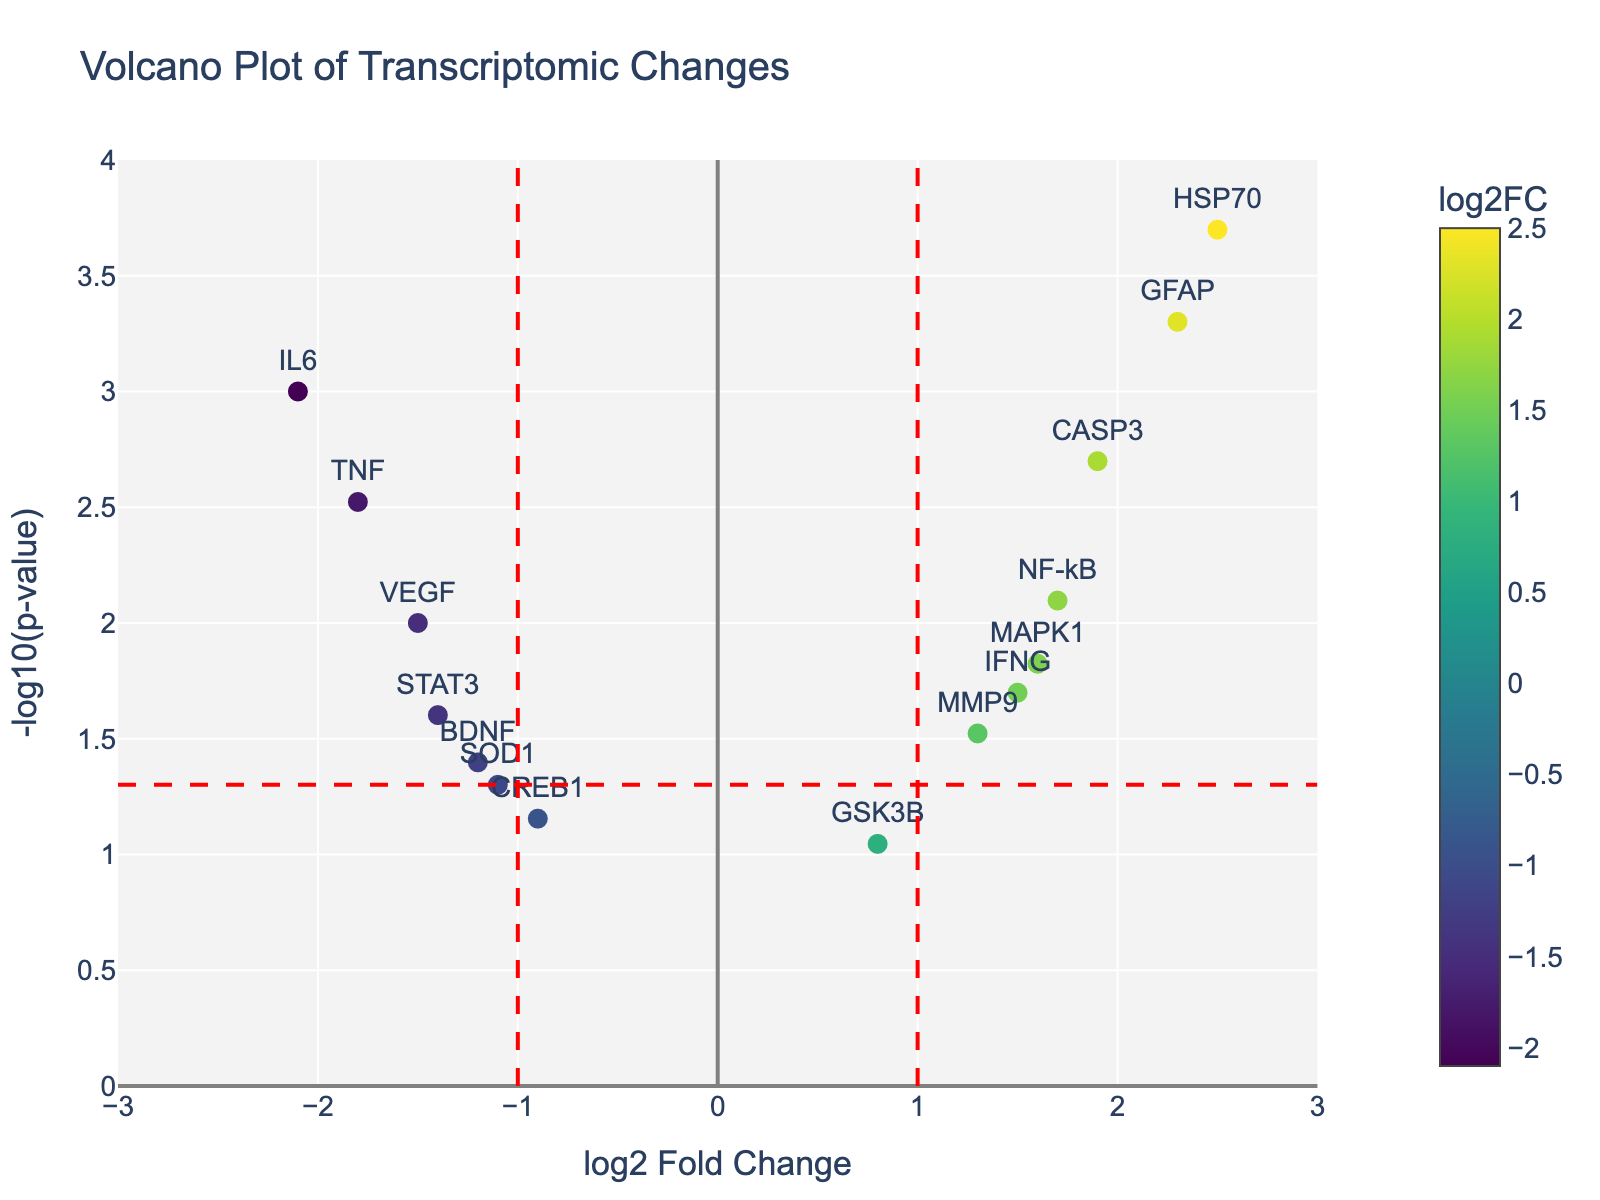How many genes have a log2 fold change greater than 1? Count the number of genes that have a log2 fold change greater than 1 on the x-axis.
Answer: 5 Which gene has the lowest p-value? Identify the data point with the highest -log10(p-value) on the y-axis, which corresponds to the lowest p-value. This gene is HSP70, standing highest on the plot.
Answer: HSP70 What is the range of log2 fold change values displayed on the x-axis? The x-axis shows values from -3 to 3 as indicated by the axis range provided in the plot settings.
Answer: -3 to 3 Are there any genes with a log2 fold change of 0? Visually scan the x-axis for any data points located at 0; none of the points are at this position.
Answer: No How many genes have significant changes (p < 0.05)? Count the number of data points above the horizontal threshold line representing p = 0.05 (-log10(0.05) on the y-axis). In this case, there are 10 points above the threshold.
Answer: 10 Which gene has the highest absolute log2 fold change? Check both ends of the x-axis; GFAP and HSP70 both have high values. The highest absolute log2 fold change is for HSP70 (2.5).
Answer: HSP70 What is the log2 fold change of the gene TNF? Locate the gene TNF on the plot by its label and read its x-axis value, which is -1.8.
Answer: -1.8 Is IL6 upregulated or downregulated? Check the position of IL6 along the x-axis; it is to the left of 0, indicating downregulation.
Answer: Downregulated Which gene lies closest to the p-value threshold of 0.05? Compare the data points near the horizontal threshold line at -log10(p-value) of 0.05; BDNF is slightly above while SOD1 is slightly below, making BDNF the correct answer as it crosses the threshold.
Answer: BDNF What is the color scheme used for the marker sizes in the plot? The question addresses the general style used for the markers, which is a size that scales with their log2 fold change, and the color scheme is 'Viridis' as implied by the description.
Answer: 'Viridis' color scale 